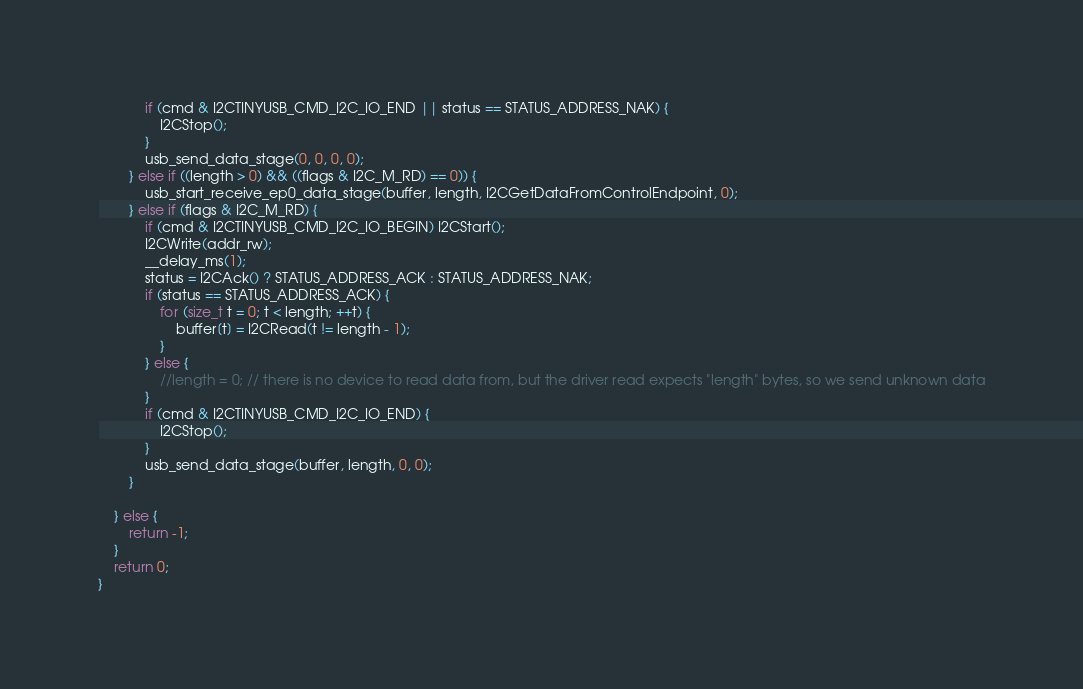<code> <loc_0><loc_0><loc_500><loc_500><_C_>            if (cmd & I2CTINYUSB_CMD_I2C_IO_END || status == STATUS_ADDRESS_NAK) {
                I2CStop();
            }
            usb_send_data_stage(0, 0, 0, 0);
        } else if ((length > 0) && ((flags & I2C_M_RD) == 0)) {
            usb_start_receive_ep0_data_stage(buffer, length, I2CGetDataFromControlEndpoint, 0);
        } else if (flags & I2C_M_RD) {
            if (cmd & I2CTINYUSB_CMD_I2C_IO_BEGIN) I2CStart();
            I2CWrite(addr_rw);
            __delay_ms(1);
            status = I2CAck() ? STATUS_ADDRESS_ACK : STATUS_ADDRESS_NAK;
            if (status == STATUS_ADDRESS_ACK) {
                for (size_t t = 0; t < length; ++t) {
                    buffer[t] = I2CRead(t != length - 1);
                }
            } else {
                //length = 0; // there is no device to read data from, but the driver read expects "length" bytes, so we send unknown data
            }
            if (cmd & I2CTINYUSB_CMD_I2C_IO_END) {
                I2CStop();
            }
            usb_send_data_stage(buffer, length, 0, 0);
        }

    } else {
        return -1;
    }
    return 0;
}
</code> 